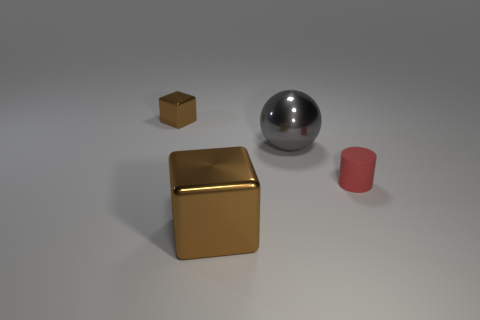What number of small objects are behind the brown metal cube that is behind the tiny thing in front of the large shiny sphere?
Ensure brevity in your answer.  0. Are there any other things that have the same size as the ball?
Provide a short and direct response. Yes. Is the size of the gray object the same as the brown cube in front of the tiny cube?
Offer a terse response. Yes. What number of large cyan rubber cylinders are there?
Offer a terse response. 0. Do the brown thing in front of the tiny matte thing and the red matte object that is in front of the small brown cube have the same size?
Your answer should be compact. No. What is the color of the other shiny object that is the same shape as the big brown metal thing?
Give a very brief answer. Brown. Does the red matte object have the same shape as the tiny brown shiny object?
Make the answer very short. No. What size is the other brown thing that is the same shape as the small brown object?
Your answer should be very brief. Large. How many small gray spheres have the same material as the big gray thing?
Your response must be concise. 0. What number of things are either big metallic objects or small brown rubber cylinders?
Provide a short and direct response. 2. 